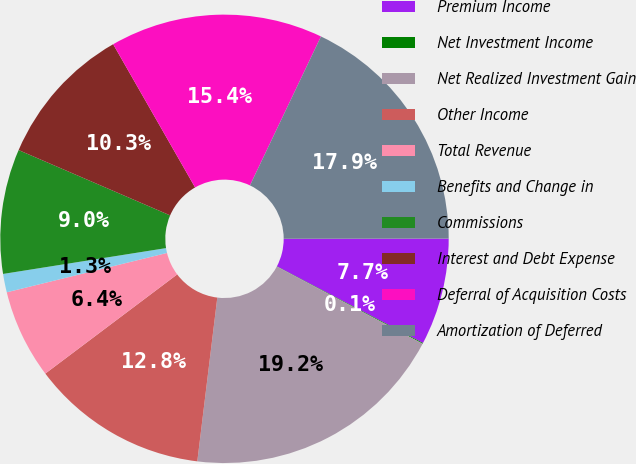Convert chart to OTSL. <chart><loc_0><loc_0><loc_500><loc_500><pie_chart><fcel>Premium Income<fcel>Net Investment Income<fcel>Net Realized Investment Gain<fcel>Other Income<fcel>Total Revenue<fcel>Benefits and Change in<fcel>Commissions<fcel>Interest and Debt Expense<fcel>Deferral of Acquisition Costs<fcel>Amortization of Deferred<nl><fcel>7.71%<fcel>0.06%<fcel>19.18%<fcel>12.8%<fcel>6.43%<fcel>1.33%<fcel>8.98%<fcel>10.25%<fcel>15.35%<fcel>17.9%<nl></chart> 